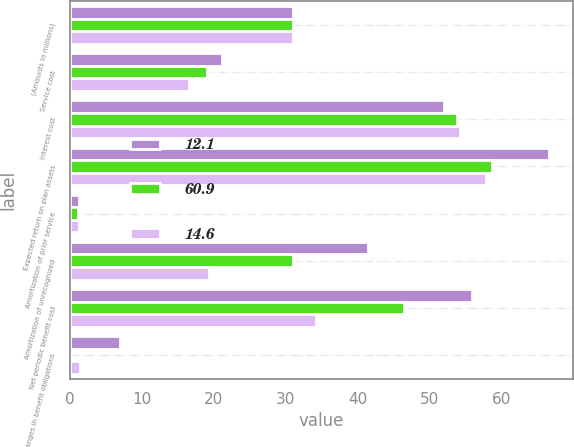<chart> <loc_0><loc_0><loc_500><loc_500><stacked_bar_chart><ecel><fcel>(Amounts in millions)<fcel>Service cost<fcel>Interest cost<fcel>Expected return on plan assets<fcel>Amortization of prior service<fcel>Amortization of unrecognized<fcel>Net periodic benefit cost<fcel>Changes in benefit obligations<nl><fcel>12.1<fcel>31.1<fcel>21.1<fcel>52<fcel>66.6<fcel>1.2<fcel>41.4<fcel>55.9<fcel>7<nl><fcel>60.9<fcel>31.1<fcel>19.1<fcel>53.9<fcel>58.7<fcel>1.1<fcel>31.1<fcel>46.5<fcel>0.2<nl><fcel>14.6<fcel>31.1<fcel>16.5<fcel>54.2<fcel>57.9<fcel>1.2<fcel>19.4<fcel>34.3<fcel>1.4<nl></chart> 